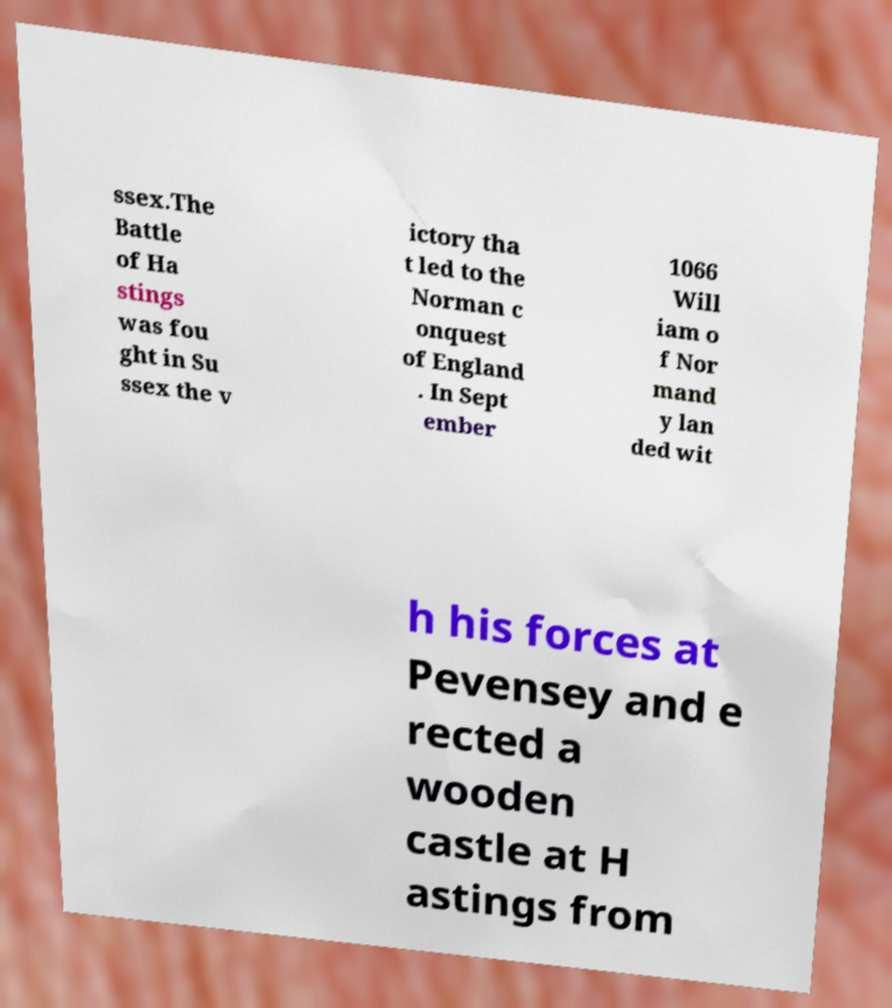Can you read and provide the text displayed in the image?This photo seems to have some interesting text. Can you extract and type it out for me? ssex.The Battle of Ha stings was fou ght in Su ssex the v ictory tha t led to the Norman c onquest of England . In Sept ember 1066 Will iam o f Nor mand y lan ded wit h his forces at Pevensey and e rected a wooden castle at H astings from 